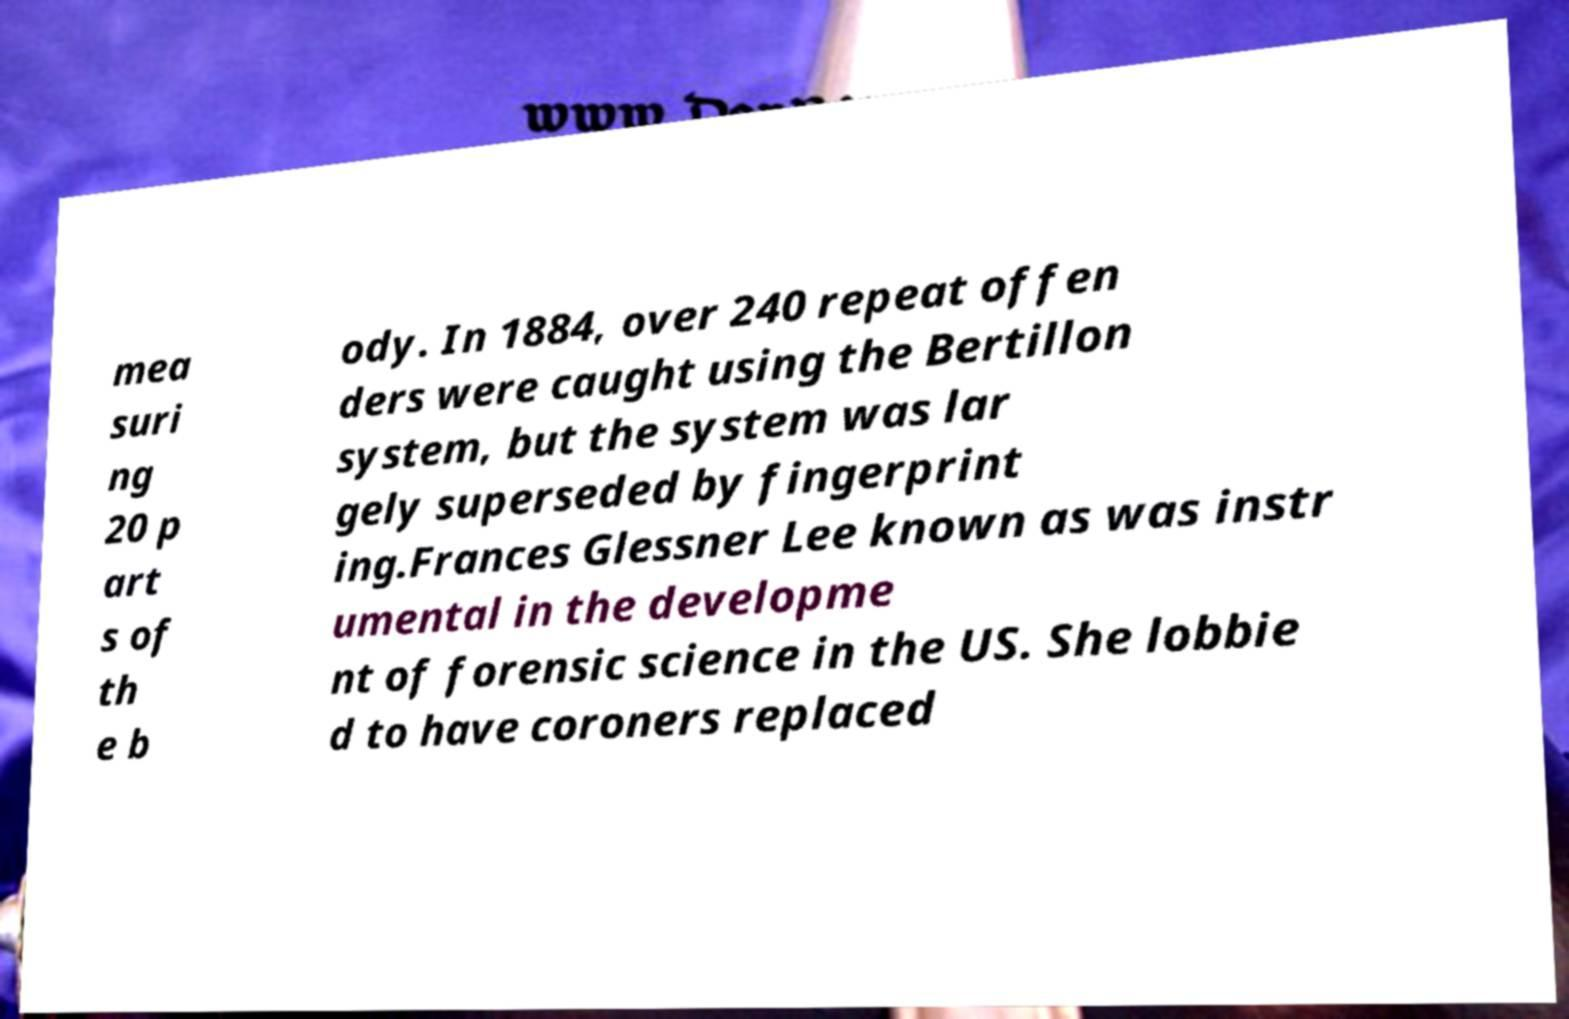Can you read and provide the text displayed in the image?This photo seems to have some interesting text. Can you extract and type it out for me? mea suri ng 20 p art s of th e b ody. In 1884, over 240 repeat offen ders were caught using the Bertillon system, but the system was lar gely superseded by fingerprint ing.Frances Glessner Lee known as was instr umental in the developme nt of forensic science in the US. She lobbie d to have coroners replaced 